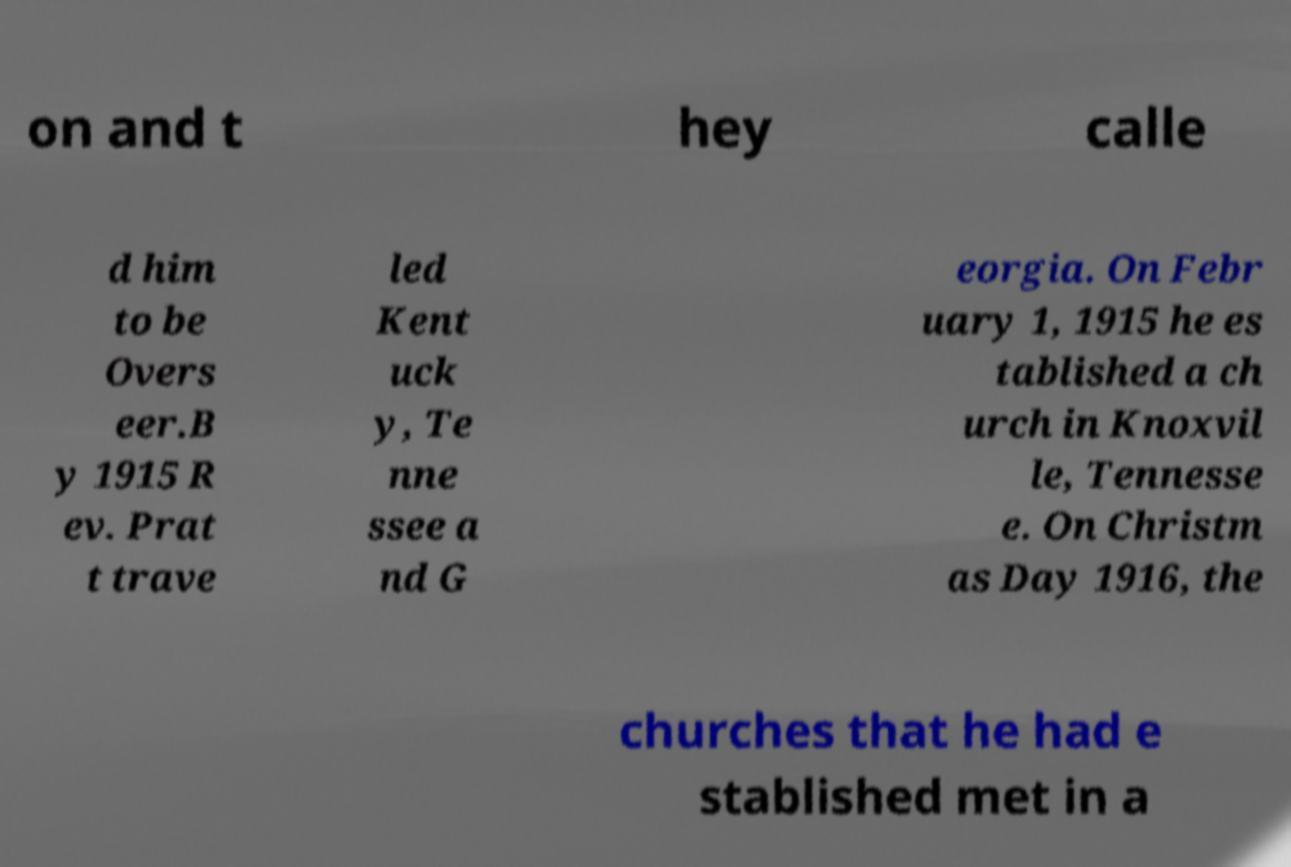Please read and relay the text visible in this image. What does it say? on and t hey calle d him to be Overs eer.B y 1915 R ev. Prat t trave led Kent uck y, Te nne ssee a nd G eorgia. On Febr uary 1, 1915 he es tablished a ch urch in Knoxvil le, Tennesse e. On Christm as Day 1916, the churches that he had e stablished met in a 